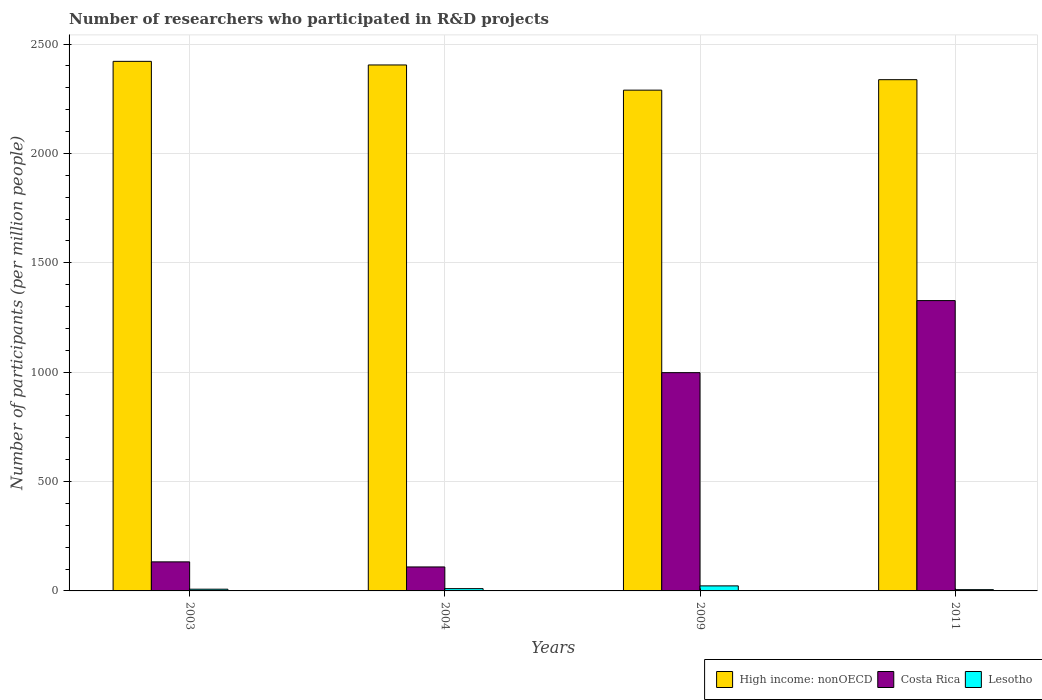How many different coloured bars are there?
Give a very brief answer. 3. How many groups of bars are there?
Your answer should be compact. 4. Are the number of bars on each tick of the X-axis equal?
Make the answer very short. Yes. How many bars are there on the 1st tick from the left?
Offer a terse response. 3. How many bars are there on the 3rd tick from the right?
Your response must be concise. 3. What is the label of the 2nd group of bars from the left?
Provide a short and direct response. 2004. In how many cases, is the number of bars for a given year not equal to the number of legend labels?
Offer a terse response. 0. What is the number of researchers who participated in R&D projects in Costa Rica in 2003?
Provide a short and direct response. 132.82. Across all years, what is the maximum number of researchers who participated in R&D projects in Costa Rica?
Make the answer very short. 1327.47. Across all years, what is the minimum number of researchers who participated in R&D projects in Costa Rica?
Keep it short and to the point. 109.62. What is the total number of researchers who participated in R&D projects in Costa Rica in the graph?
Offer a terse response. 2567.85. What is the difference between the number of researchers who participated in R&D projects in High income: nonOECD in 2009 and that in 2011?
Keep it short and to the point. -47.9. What is the difference between the number of researchers who participated in R&D projects in Lesotho in 2009 and the number of researchers who participated in R&D projects in High income: nonOECD in 2004?
Keep it short and to the point. -2381.68. What is the average number of researchers who participated in R&D projects in Lesotho per year?
Provide a succinct answer. 11.81. In the year 2011, what is the difference between the number of researchers who participated in R&D projects in Lesotho and number of researchers who participated in R&D projects in High income: nonOECD?
Provide a short and direct response. -2331.61. In how many years, is the number of researchers who participated in R&D projects in High income: nonOECD greater than 2000?
Your answer should be very brief. 4. What is the ratio of the number of researchers who participated in R&D projects in Lesotho in 2004 to that in 2011?
Ensure brevity in your answer.  1.79. What is the difference between the highest and the second highest number of researchers who participated in R&D projects in Lesotho?
Provide a succinct answer. 12.55. What is the difference between the highest and the lowest number of researchers who participated in R&D projects in Costa Rica?
Ensure brevity in your answer.  1217.84. What does the 3rd bar from the left in 2011 represents?
Keep it short and to the point. Lesotho. What does the 1st bar from the right in 2003 represents?
Your answer should be very brief. Lesotho. Is it the case that in every year, the sum of the number of researchers who participated in R&D projects in Lesotho and number of researchers who participated in R&D projects in Costa Rica is greater than the number of researchers who participated in R&D projects in High income: nonOECD?
Keep it short and to the point. No. Are the values on the major ticks of Y-axis written in scientific E-notation?
Give a very brief answer. No. How are the legend labels stacked?
Your response must be concise. Horizontal. What is the title of the graph?
Offer a very short reply. Number of researchers who participated in R&D projects. Does "Armenia" appear as one of the legend labels in the graph?
Make the answer very short. No. What is the label or title of the Y-axis?
Make the answer very short. Number of participants (per million people). What is the Number of participants (per million people) in High income: nonOECD in 2003?
Offer a terse response. 2421.22. What is the Number of participants (per million people) in Costa Rica in 2003?
Your answer should be very brief. 132.82. What is the Number of participants (per million people) of Lesotho in 2003?
Keep it short and to the point. 7.9. What is the Number of participants (per million people) of High income: nonOECD in 2004?
Give a very brief answer. 2404.69. What is the Number of participants (per million people) in Costa Rica in 2004?
Provide a succinct answer. 109.62. What is the Number of participants (per million people) of Lesotho in 2004?
Ensure brevity in your answer.  10.46. What is the Number of participants (per million people) of High income: nonOECD in 2009?
Provide a succinct answer. 2289.56. What is the Number of participants (per million people) in Costa Rica in 2009?
Provide a short and direct response. 997.94. What is the Number of participants (per million people) of Lesotho in 2009?
Your response must be concise. 23.01. What is the Number of participants (per million people) in High income: nonOECD in 2011?
Your answer should be very brief. 2337.46. What is the Number of participants (per million people) in Costa Rica in 2011?
Your answer should be very brief. 1327.47. What is the Number of participants (per million people) in Lesotho in 2011?
Provide a short and direct response. 5.85. Across all years, what is the maximum Number of participants (per million people) in High income: nonOECD?
Keep it short and to the point. 2421.22. Across all years, what is the maximum Number of participants (per million people) of Costa Rica?
Your answer should be compact. 1327.47. Across all years, what is the maximum Number of participants (per million people) of Lesotho?
Give a very brief answer. 23.01. Across all years, what is the minimum Number of participants (per million people) of High income: nonOECD?
Provide a succinct answer. 2289.56. Across all years, what is the minimum Number of participants (per million people) of Costa Rica?
Offer a very short reply. 109.62. Across all years, what is the minimum Number of participants (per million people) in Lesotho?
Provide a succinct answer. 5.85. What is the total Number of participants (per million people) in High income: nonOECD in the graph?
Keep it short and to the point. 9452.94. What is the total Number of participants (per million people) in Costa Rica in the graph?
Provide a succinct answer. 2567.85. What is the total Number of participants (per million people) in Lesotho in the graph?
Your answer should be compact. 47.22. What is the difference between the Number of participants (per million people) in High income: nonOECD in 2003 and that in 2004?
Offer a very short reply. 16.53. What is the difference between the Number of participants (per million people) in Costa Rica in 2003 and that in 2004?
Offer a terse response. 23.19. What is the difference between the Number of participants (per million people) in Lesotho in 2003 and that in 2004?
Keep it short and to the point. -2.56. What is the difference between the Number of participants (per million people) of High income: nonOECD in 2003 and that in 2009?
Your answer should be compact. 131.66. What is the difference between the Number of participants (per million people) of Costa Rica in 2003 and that in 2009?
Offer a very short reply. -865.12. What is the difference between the Number of participants (per million people) of Lesotho in 2003 and that in 2009?
Give a very brief answer. -15.11. What is the difference between the Number of participants (per million people) of High income: nonOECD in 2003 and that in 2011?
Your answer should be compact. 83.76. What is the difference between the Number of participants (per million people) in Costa Rica in 2003 and that in 2011?
Keep it short and to the point. -1194.65. What is the difference between the Number of participants (per million people) of Lesotho in 2003 and that in 2011?
Your response must be concise. 2.05. What is the difference between the Number of participants (per million people) of High income: nonOECD in 2004 and that in 2009?
Ensure brevity in your answer.  115.13. What is the difference between the Number of participants (per million people) of Costa Rica in 2004 and that in 2009?
Your response must be concise. -888.31. What is the difference between the Number of participants (per million people) of Lesotho in 2004 and that in 2009?
Make the answer very short. -12.55. What is the difference between the Number of participants (per million people) in High income: nonOECD in 2004 and that in 2011?
Provide a succinct answer. 67.23. What is the difference between the Number of participants (per million people) of Costa Rica in 2004 and that in 2011?
Provide a succinct answer. -1217.84. What is the difference between the Number of participants (per million people) of Lesotho in 2004 and that in 2011?
Provide a short and direct response. 4.61. What is the difference between the Number of participants (per million people) of High income: nonOECD in 2009 and that in 2011?
Keep it short and to the point. -47.9. What is the difference between the Number of participants (per million people) in Costa Rica in 2009 and that in 2011?
Ensure brevity in your answer.  -329.53. What is the difference between the Number of participants (per million people) of Lesotho in 2009 and that in 2011?
Offer a very short reply. 17.16. What is the difference between the Number of participants (per million people) in High income: nonOECD in 2003 and the Number of participants (per million people) in Costa Rica in 2004?
Keep it short and to the point. 2311.6. What is the difference between the Number of participants (per million people) of High income: nonOECD in 2003 and the Number of participants (per million people) of Lesotho in 2004?
Offer a terse response. 2410.76. What is the difference between the Number of participants (per million people) of Costa Rica in 2003 and the Number of participants (per million people) of Lesotho in 2004?
Offer a terse response. 122.36. What is the difference between the Number of participants (per million people) of High income: nonOECD in 2003 and the Number of participants (per million people) of Costa Rica in 2009?
Ensure brevity in your answer.  1423.29. What is the difference between the Number of participants (per million people) in High income: nonOECD in 2003 and the Number of participants (per million people) in Lesotho in 2009?
Your response must be concise. 2398.21. What is the difference between the Number of participants (per million people) of Costa Rica in 2003 and the Number of participants (per million people) of Lesotho in 2009?
Your response must be concise. 109.81. What is the difference between the Number of participants (per million people) in High income: nonOECD in 2003 and the Number of participants (per million people) in Costa Rica in 2011?
Ensure brevity in your answer.  1093.75. What is the difference between the Number of participants (per million people) of High income: nonOECD in 2003 and the Number of participants (per million people) of Lesotho in 2011?
Your answer should be compact. 2415.37. What is the difference between the Number of participants (per million people) in Costa Rica in 2003 and the Number of participants (per million people) in Lesotho in 2011?
Your answer should be very brief. 126.96. What is the difference between the Number of participants (per million people) of High income: nonOECD in 2004 and the Number of participants (per million people) of Costa Rica in 2009?
Keep it short and to the point. 1406.76. What is the difference between the Number of participants (per million people) of High income: nonOECD in 2004 and the Number of participants (per million people) of Lesotho in 2009?
Ensure brevity in your answer.  2381.68. What is the difference between the Number of participants (per million people) of Costa Rica in 2004 and the Number of participants (per million people) of Lesotho in 2009?
Ensure brevity in your answer.  86.61. What is the difference between the Number of participants (per million people) of High income: nonOECD in 2004 and the Number of participants (per million people) of Costa Rica in 2011?
Provide a succinct answer. 1077.22. What is the difference between the Number of participants (per million people) of High income: nonOECD in 2004 and the Number of participants (per million people) of Lesotho in 2011?
Your answer should be very brief. 2398.84. What is the difference between the Number of participants (per million people) of Costa Rica in 2004 and the Number of participants (per million people) of Lesotho in 2011?
Give a very brief answer. 103.77. What is the difference between the Number of participants (per million people) in High income: nonOECD in 2009 and the Number of participants (per million people) in Costa Rica in 2011?
Your answer should be compact. 962.09. What is the difference between the Number of participants (per million people) of High income: nonOECD in 2009 and the Number of participants (per million people) of Lesotho in 2011?
Give a very brief answer. 2283.71. What is the difference between the Number of participants (per million people) in Costa Rica in 2009 and the Number of participants (per million people) in Lesotho in 2011?
Ensure brevity in your answer.  992.08. What is the average Number of participants (per million people) of High income: nonOECD per year?
Your response must be concise. 2363.24. What is the average Number of participants (per million people) in Costa Rica per year?
Offer a terse response. 641.96. What is the average Number of participants (per million people) in Lesotho per year?
Give a very brief answer. 11.81. In the year 2003, what is the difference between the Number of participants (per million people) of High income: nonOECD and Number of participants (per million people) of Costa Rica?
Offer a terse response. 2288.41. In the year 2003, what is the difference between the Number of participants (per million people) in High income: nonOECD and Number of participants (per million people) in Lesotho?
Make the answer very short. 2413.32. In the year 2003, what is the difference between the Number of participants (per million people) in Costa Rica and Number of participants (per million people) in Lesotho?
Ensure brevity in your answer.  124.92. In the year 2004, what is the difference between the Number of participants (per million people) of High income: nonOECD and Number of participants (per million people) of Costa Rica?
Your answer should be compact. 2295.07. In the year 2004, what is the difference between the Number of participants (per million people) in High income: nonOECD and Number of participants (per million people) in Lesotho?
Keep it short and to the point. 2394.23. In the year 2004, what is the difference between the Number of participants (per million people) of Costa Rica and Number of participants (per million people) of Lesotho?
Ensure brevity in your answer.  99.16. In the year 2009, what is the difference between the Number of participants (per million people) of High income: nonOECD and Number of participants (per million people) of Costa Rica?
Offer a terse response. 1291.63. In the year 2009, what is the difference between the Number of participants (per million people) of High income: nonOECD and Number of participants (per million people) of Lesotho?
Your response must be concise. 2266.55. In the year 2009, what is the difference between the Number of participants (per million people) in Costa Rica and Number of participants (per million people) in Lesotho?
Offer a very short reply. 974.93. In the year 2011, what is the difference between the Number of participants (per million people) in High income: nonOECD and Number of participants (per million people) in Costa Rica?
Your answer should be very brief. 1010. In the year 2011, what is the difference between the Number of participants (per million people) in High income: nonOECD and Number of participants (per million people) in Lesotho?
Ensure brevity in your answer.  2331.61. In the year 2011, what is the difference between the Number of participants (per million people) in Costa Rica and Number of participants (per million people) in Lesotho?
Your answer should be very brief. 1321.61. What is the ratio of the Number of participants (per million people) in High income: nonOECD in 2003 to that in 2004?
Offer a very short reply. 1.01. What is the ratio of the Number of participants (per million people) of Costa Rica in 2003 to that in 2004?
Offer a very short reply. 1.21. What is the ratio of the Number of participants (per million people) of Lesotho in 2003 to that in 2004?
Keep it short and to the point. 0.76. What is the ratio of the Number of participants (per million people) in High income: nonOECD in 2003 to that in 2009?
Make the answer very short. 1.06. What is the ratio of the Number of participants (per million people) of Costa Rica in 2003 to that in 2009?
Ensure brevity in your answer.  0.13. What is the ratio of the Number of participants (per million people) of Lesotho in 2003 to that in 2009?
Ensure brevity in your answer.  0.34. What is the ratio of the Number of participants (per million people) in High income: nonOECD in 2003 to that in 2011?
Offer a very short reply. 1.04. What is the ratio of the Number of participants (per million people) in Costa Rica in 2003 to that in 2011?
Provide a succinct answer. 0.1. What is the ratio of the Number of participants (per million people) in Lesotho in 2003 to that in 2011?
Your answer should be compact. 1.35. What is the ratio of the Number of participants (per million people) of High income: nonOECD in 2004 to that in 2009?
Keep it short and to the point. 1.05. What is the ratio of the Number of participants (per million people) in Costa Rica in 2004 to that in 2009?
Your answer should be compact. 0.11. What is the ratio of the Number of participants (per million people) in Lesotho in 2004 to that in 2009?
Your answer should be compact. 0.45. What is the ratio of the Number of participants (per million people) of High income: nonOECD in 2004 to that in 2011?
Your answer should be very brief. 1.03. What is the ratio of the Number of participants (per million people) of Costa Rica in 2004 to that in 2011?
Keep it short and to the point. 0.08. What is the ratio of the Number of participants (per million people) of Lesotho in 2004 to that in 2011?
Give a very brief answer. 1.79. What is the ratio of the Number of participants (per million people) in High income: nonOECD in 2009 to that in 2011?
Provide a short and direct response. 0.98. What is the ratio of the Number of participants (per million people) in Costa Rica in 2009 to that in 2011?
Your answer should be very brief. 0.75. What is the ratio of the Number of participants (per million people) of Lesotho in 2009 to that in 2011?
Offer a terse response. 3.93. What is the difference between the highest and the second highest Number of participants (per million people) in High income: nonOECD?
Your response must be concise. 16.53. What is the difference between the highest and the second highest Number of participants (per million people) of Costa Rica?
Your answer should be very brief. 329.53. What is the difference between the highest and the second highest Number of participants (per million people) of Lesotho?
Provide a succinct answer. 12.55. What is the difference between the highest and the lowest Number of participants (per million people) of High income: nonOECD?
Your answer should be compact. 131.66. What is the difference between the highest and the lowest Number of participants (per million people) in Costa Rica?
Offer a terse response. 1217.84. What is the difference between the highest and the lowest Number of participants (per million people) in Lesotho?
Make the answer very short. 17.16. 